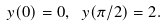<formula> <loc_0><loc_0><loc_500><loc_500>y ( 0 ) = 0 , \ y ( \pi / 2 ) = 2 .</formula> 